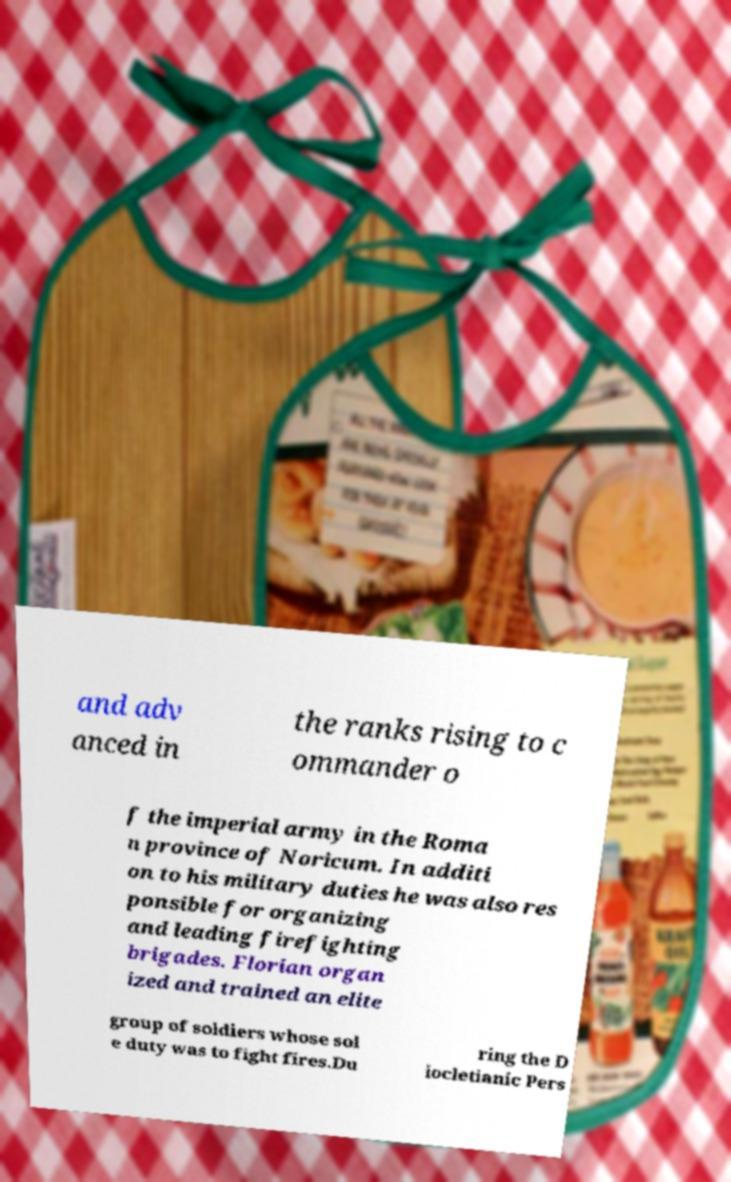What messages or text are displayed in this image? I need them in a readable, typed format. and adv anced in the ranks rising to c ommander o f the imperial army in the Roma n province of Noricum. In additi on to his military duties he was also res ponsible for organizing and leading firefighting brigades. Florian organ ized and trained an elite group of soldiers whose sol e duty was to fight fires.Du ring the D iocletianic Pers 